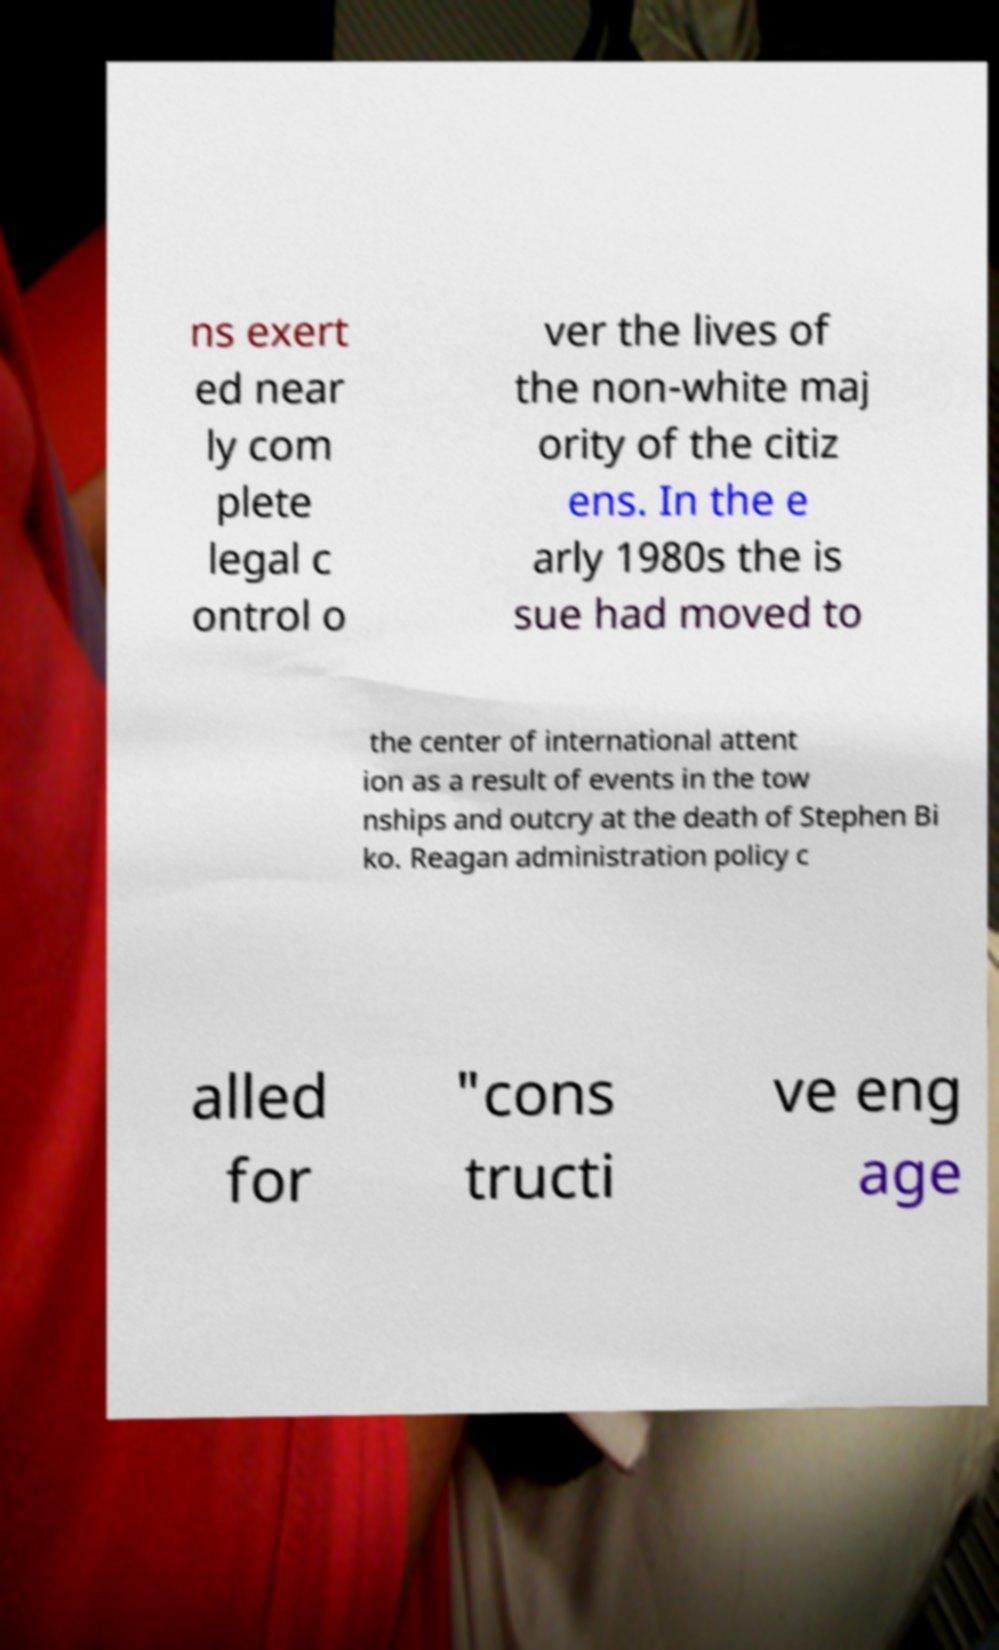I need the written content from this picture converted into text. Can you do that? ns exert ed near ly com plete legal c ontrol o ver the lives of the non-white maj ority of the citiz ens. In the e arly 1980s the is sue had moved to the center of international attent ion as a result of events in the tow nships and outcry at the death of Stephen Bi ko. Reagan administration policy c alled for "cons tructi ve eng age 